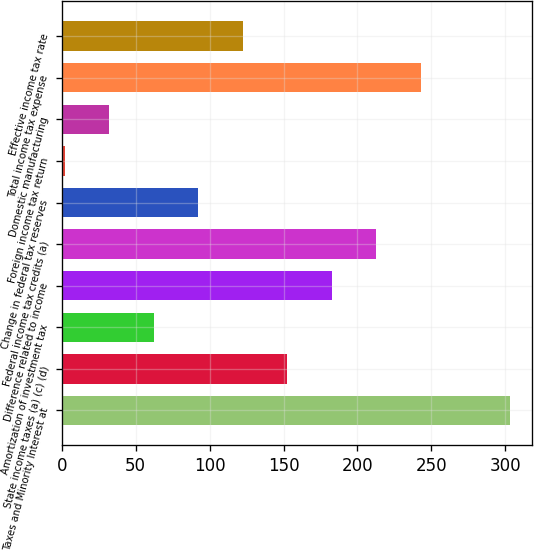<chart> <loc_0><loc_0><loc_500><loc_500><bar_chart><fcel>Taxes and Minority Interest at<fcel>State income taxes (a) (c) (d)<fcel>Amortization of investment tax<fcel>Difference related to income<fcel>Federal income tax credits (a)<fcel>Change in federal tax reserves<fcel>Foreign income tax return<fcel>Domestic manufacturing<fcel>Total income tax expense<fcel>Effective income tax rate<nl><fcel>303<fcel>152.5<fcel>62.2<fcel>182.6<fcel>212.7<fcel>92.3<fcel>2<fcel>32.1<fcel>242.8<fcel>122.4<nl></chart> 